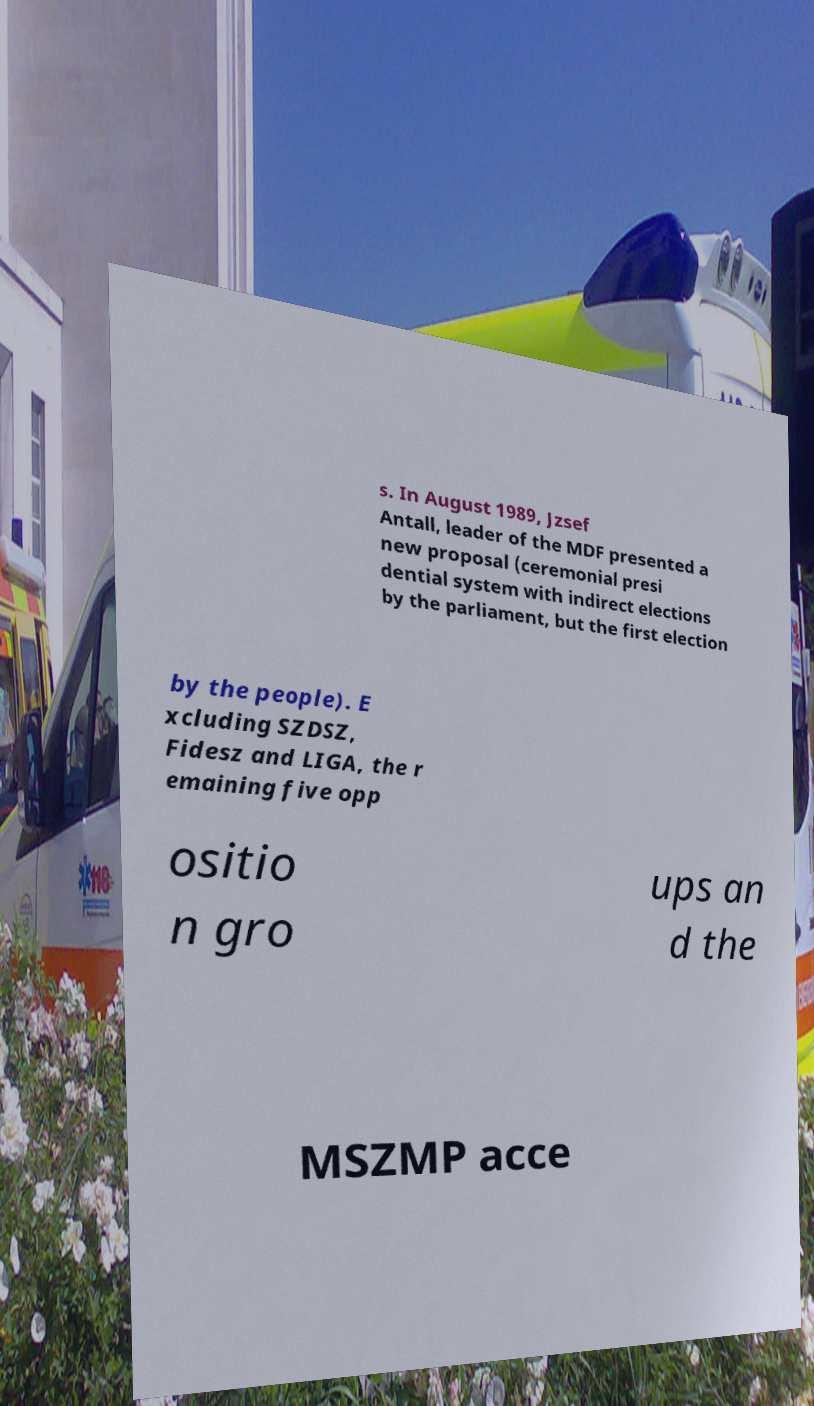Please read and relay the text visible in this image. What does it say? s. In August 1989, Jzsef Antall, leader of the MDF presented a new proposal (ceremonial presi dential system with indirect elections by the parliament, but the first election by the people). E xcluding SZDSZ, Fidesz and LIGA, the r emaining five opp ositio n gro ups an d the MSZMP acce 